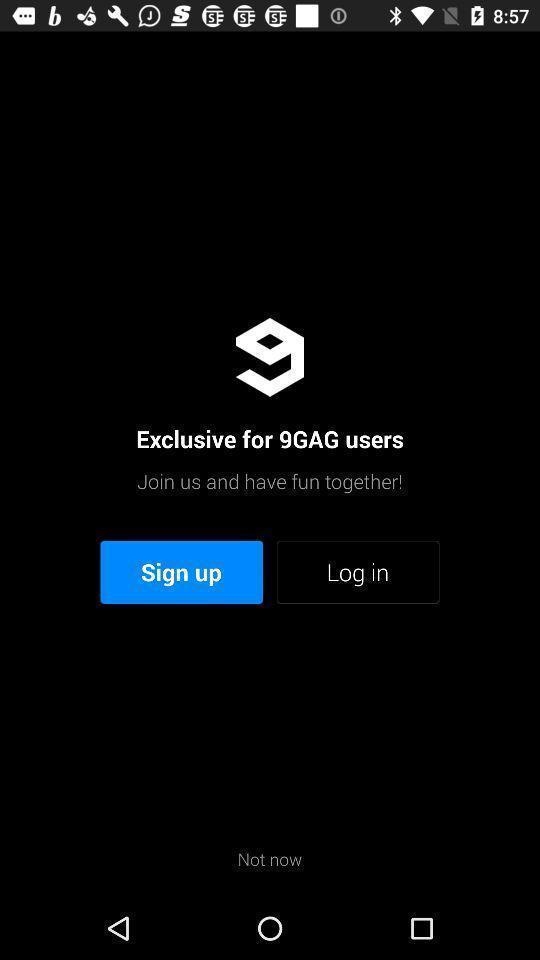Tell me what you see in this picture. Welcome page. 